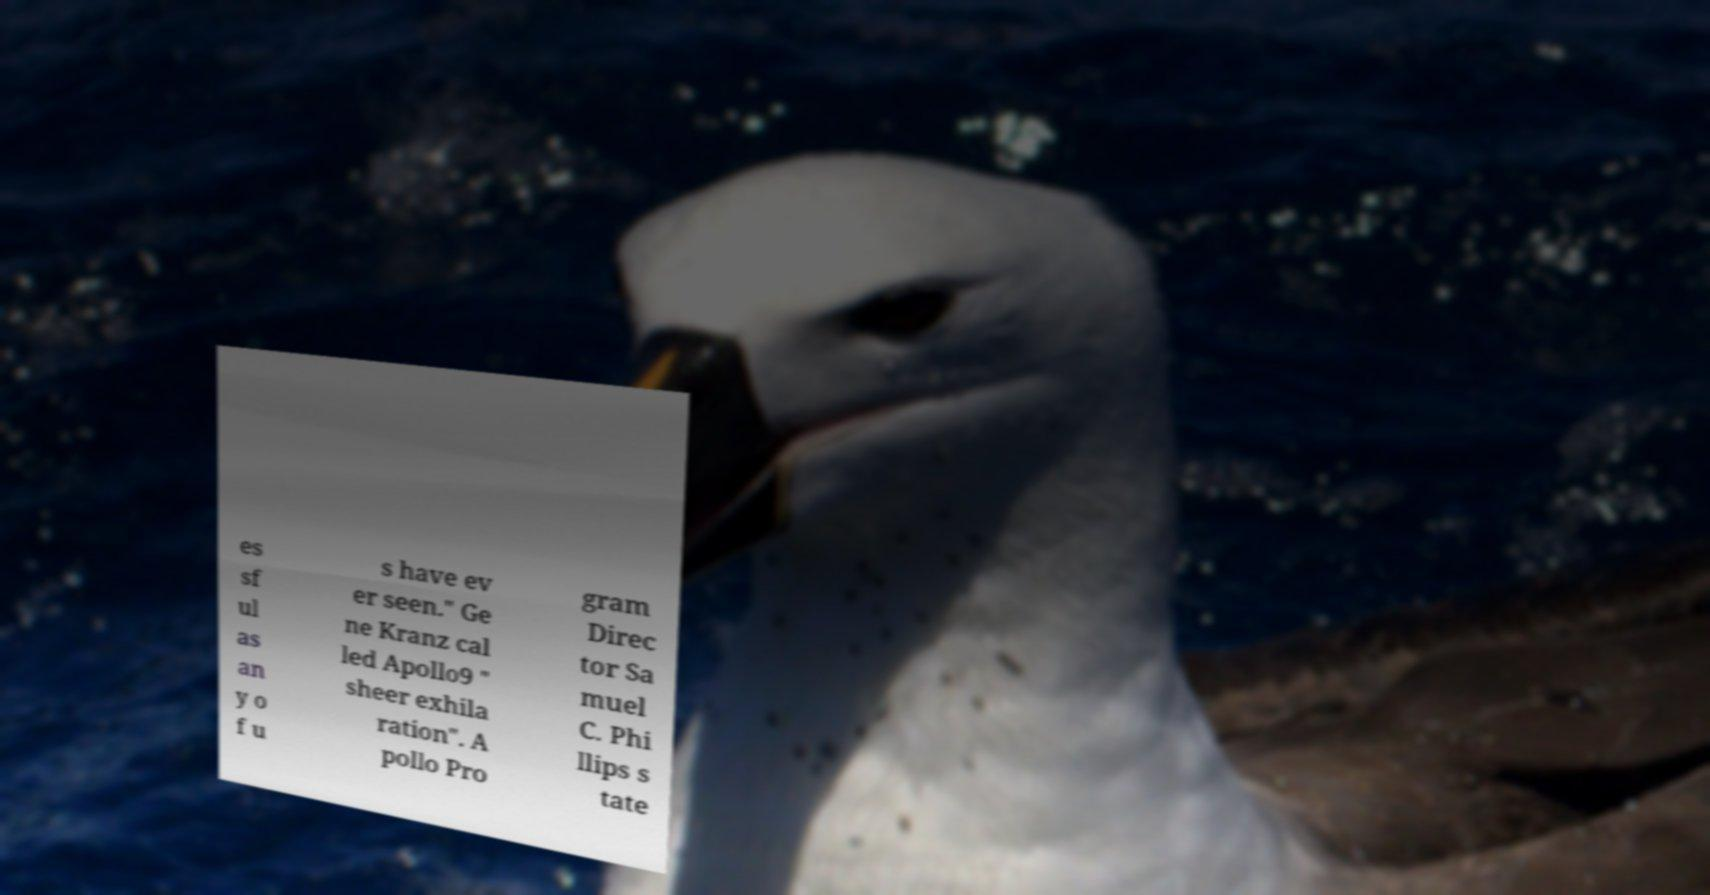For documentation purposes, I need the text within this image transcribed. Could you provide that? es sf ul as an y o f u s have ev er seen." Ge ne Kranz cal led Apollo9 " sheer exhila ration". A pollo Pro gram Direc tor Sa muel C. Phi llips s tate 